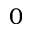Convert formula to latex. <formula><loc_0><loc_0><loc_500><loc_500>0</formula> 